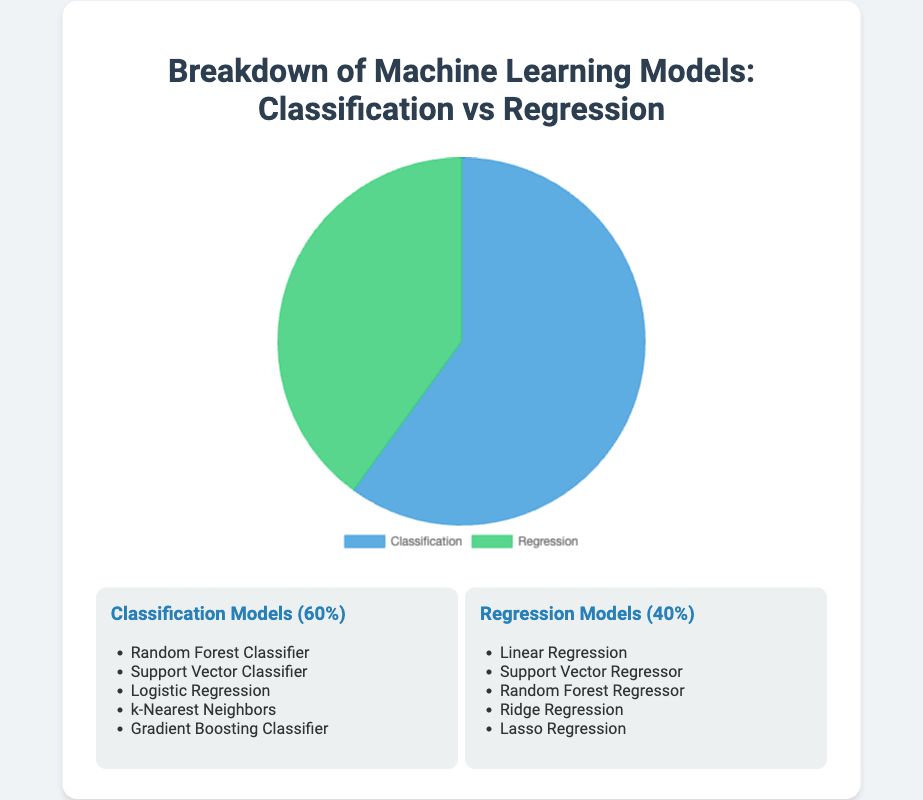What percentage of the machine learning models are used for classification tasks? The pie chart visually represents the distribution of machine learning models. To find the percentage used for classification tasks, we refer to the segment labeled "Classification".
Answer: 60% What is the percentage difference between classification and regression models? The proportions of classification and regression models are 60% and 40%, respectively. Subtract the percentage of regression models from that of classification models (60% - 40%).
Answer: 20% Which type of machine learning model is more prevalent, classification or regression? The pie chart shows that the section for classification is larger compared to regression. The respective percentages are 60% for classification and 40% for regression.
Answer: Classification What is the total percentage represented in the pie chart? A pie chart always represents a whole, which is 100%. So, adding the two segments, classification (60%) and regression (40%), gives the total percentage.
Answer: 100% What colors represent classification and regression models in the chart? The chart uses distinct colors for each segment. The color representing classification is indicated by the blue section, and regression is represented by the green section.
Answer: Blue for classification, green for regression List the types of models used for classification and regression tasks shown in the chart. The pie chart does not display the exact model names, but the descriptions below it list them. Classification includes: Random Forest Classifier, Support Vector Classifier, Logistic Regression, k-Nearest Neighbors, Gradient Boosting Classifier. Regression includes: Linear Regression, Support Vector Regressor, Random Forest Regressor, Ridge Regression, Lasso Regression.
Answer: Classification: Random Forest Classifier, Support Vector Classifier, Logistic Regression, k-Nearest Neighbors, Gradient Boosting Classifier. Regression: Linear Regression, Support Vector Regressor, Random Forest Regressor, Ridge Regression, Lasso Regression If you were to add a new model to the classification category, what percentage would classification models then represent? Initially, classification models represent 60% and regression models 40%. Adding a new classification model would not change the percentage distribution because the chart is based on the current data.
Answer: 60% Is there an equal number of examples listed for classification and regression models? By counting the listed examples in both categories, it shows that both classification and regression each have 5 examples listed.
Answer: Yes, there are an equal number What visual clue in the pie chart helps determine which type of model occupies the greater portion? The relative size of each segment in a pie chart helps determine the larger portion. The classification section appears larger than the regression section, indicating it occupies a greater portion.
Answer: The larger segment size of classification 